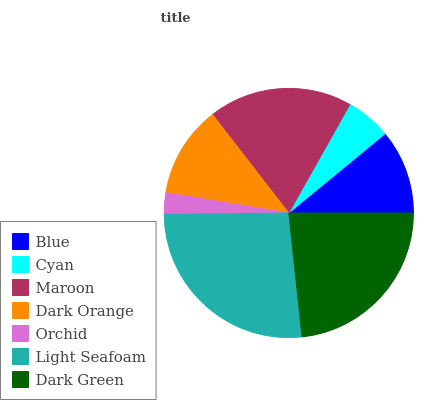Is Orchid the minimum?
Answer yes or no. Yes. Is Light Seafoam the maximum?
Answer yes or no. Yes. Is Cyan the minimum?
Answer yes or no. No. Is Cyan the maximum?
Answer yes or no. No. Is Blue greater than Cyan?
Answer yes or no. Yes. Is Cyan less than Blue?
Answer yes or no. Yes. Is Cyan greater than Blue?
Answer yes or no. No. Is Blue less than Cyan?
Answer yes or no. No. Is Dark Orange the high median?
Answer yes or no. Yes. Is Dark Orange the low median?
Answer yes or no. Yes. Is Maroon the high median?
Answer yes or no. No. Is Dark Green the low median?
Answer yes or no. No. 